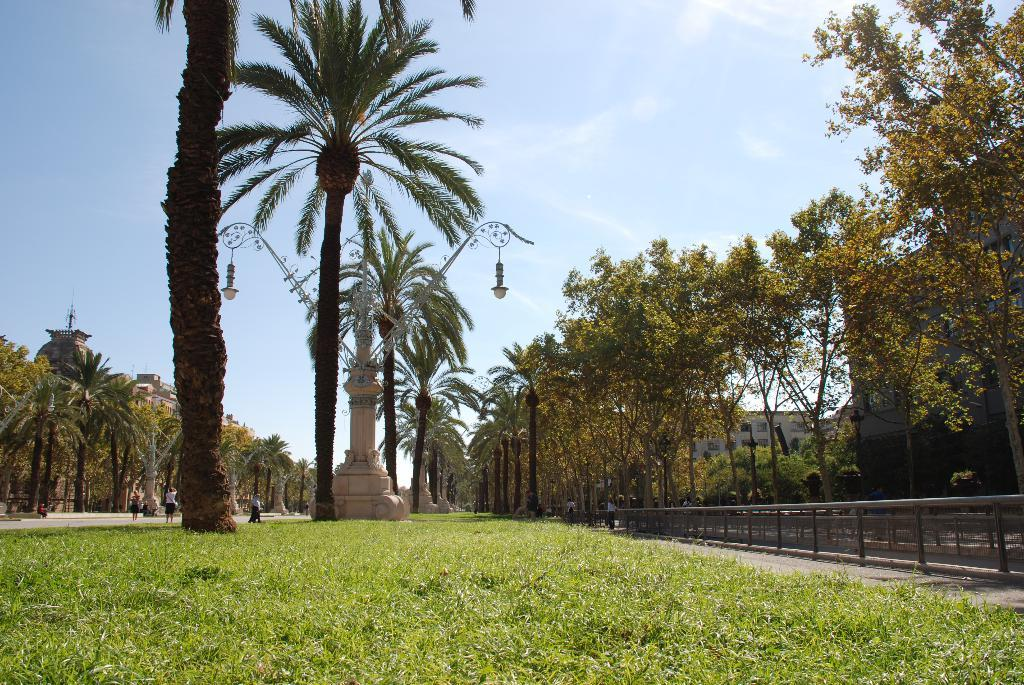What can be seen in the background of the image? In the background of the image, there are buildings, trees, people, lights, poles, grass, pillars, railings, and the sky. Can you describe the environment in the background of the image? The background of the image features a mix of natural elements like trees and grass, as well as man-made structures such as buildings, poles, pillars, and railings. There are also lights present, which could indicate a nighttime scene or a well-lit area. What is the sky like in the image? The sky is visible in the background of the image, but no specific details about its appearance are provided. What type of education can be seen in the image? There is no indication of any educational content or setting in the image. 